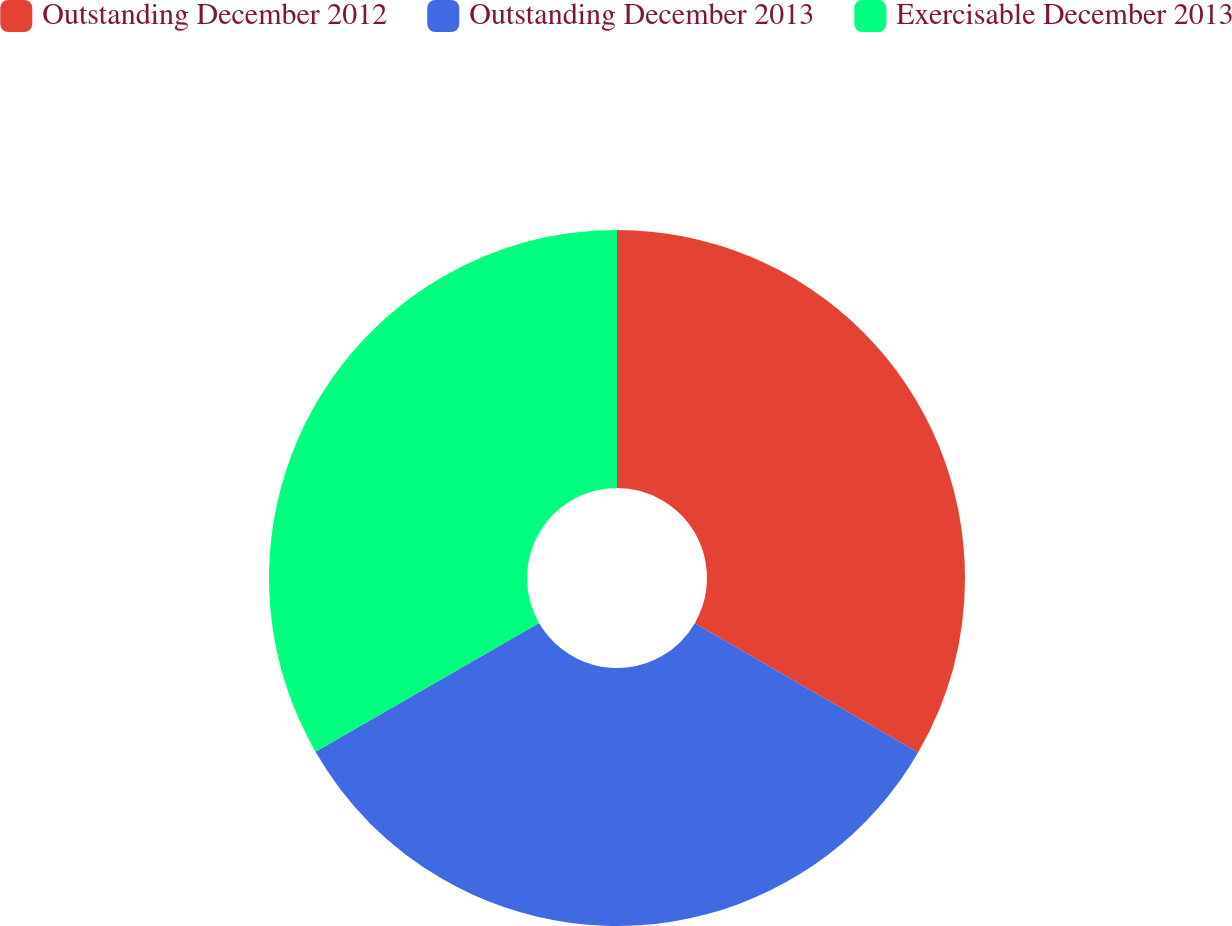Convert chart. <chart><loc_0><loc_0><loc_500><loc_500><pie_chart><fcel>Outstanding December 2012<fcel>Outstanding December 2013<fcel>Exercisable December 2013<nl><fcel>33.36%<fcel>33.32%<fcel>33.32%<nl></chart> 